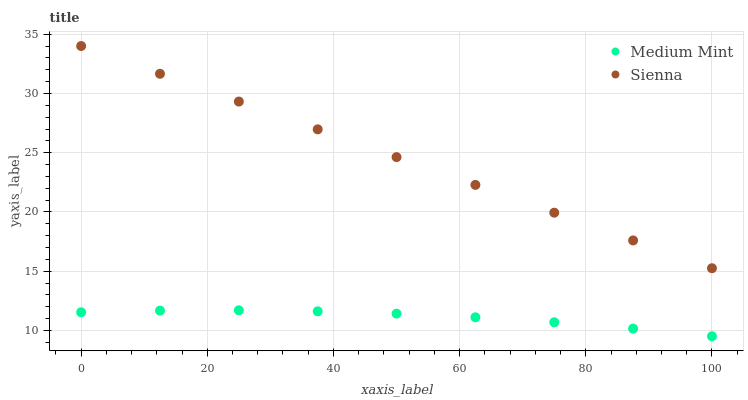Does Medium Mint have the minimum area under the curve?
Answer yes or no. Yes. Does Sienna have the maximum area under the curve?
Answer yes or no. Yes. Does Sienna have the minimum area under the curve?
Answer yes or no. No. Is Sienna the smoothest?
Answer yes or no. Yes. Is Medium Mint the roughest?
Answer yes or no. Yes. Is Sienna the roughest?
Answer yes or no. No. Does Medium Mint have the lowest value?
Answer yes or no. Yes. Does Sienna have the lowest value?
Answer yes or no. No. Does Sienna have the highest value?
Answer yes or no. Yes. Is Medium Mint less than Sienna?
Answer yes or no. Yes. Is Sienna greater than Medium Mint?
Answer yes or no. Yes. Does Medium Mint intersect Sienna?
Answer yes or no. No. 